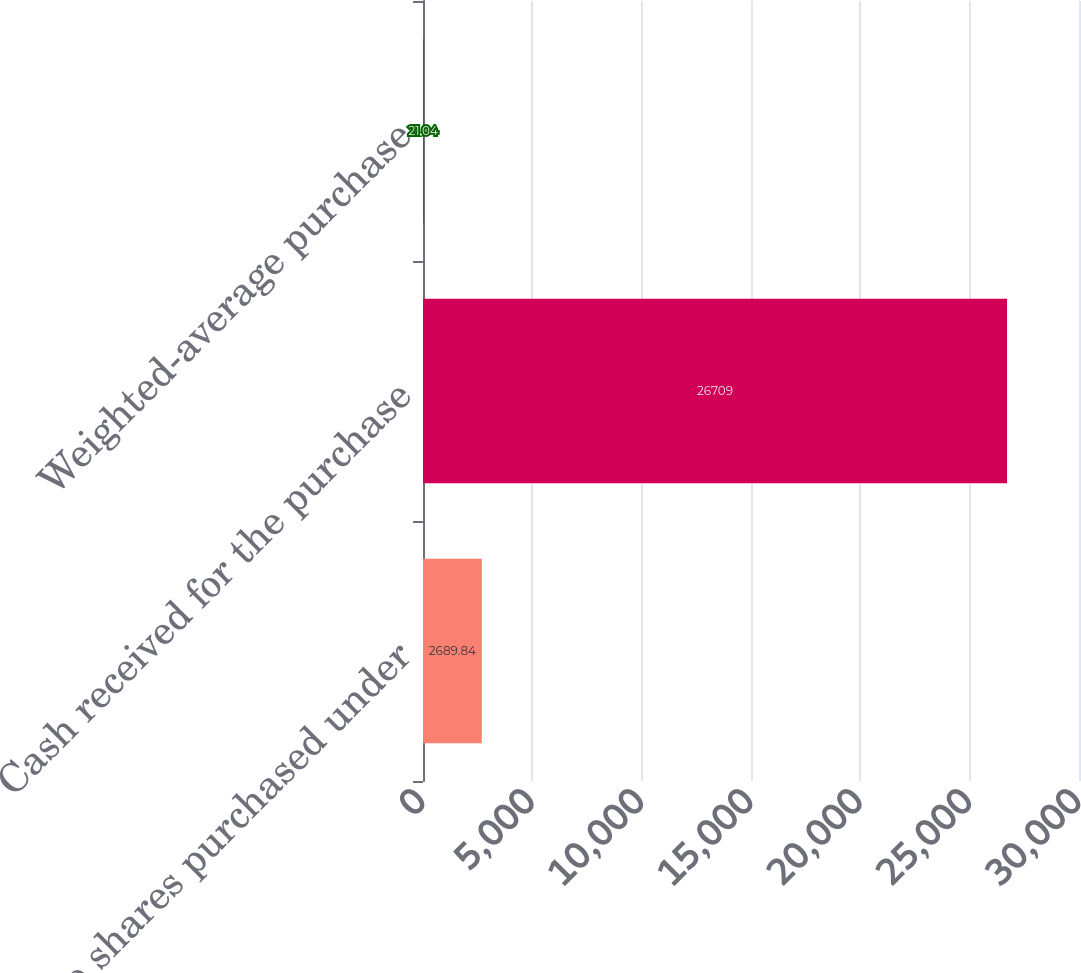Convert chart to OTSL. <chart><loc_0><loc_0><loc_500><loc_500><bar_chart><fcel>Cadence shares purchased under<fcel>Cash received for the purchase<fcel>Weighted-average purchase<nl><fcel>2689.84<fcel>26709<fcel>21.04<nl></chart> 